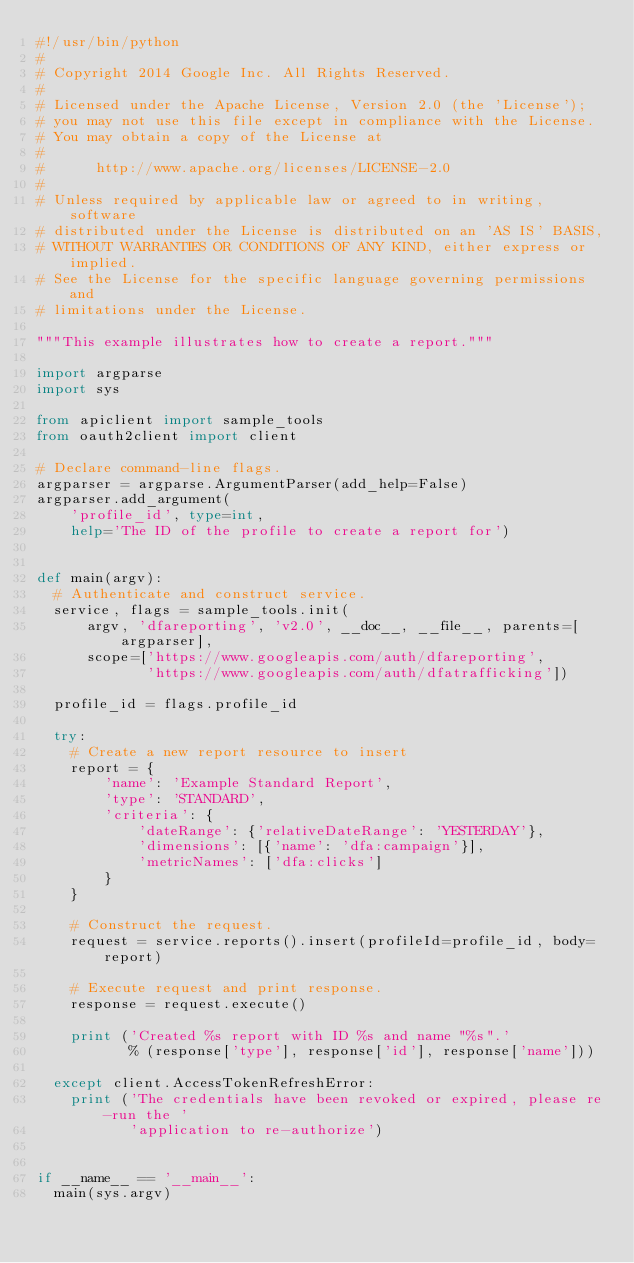Convert code to text. <code><loc_0><loc_0><loc_500><loc_500><_Python_>#!/usr/bin/python
#
# Copyright 2014 Google Inc. All Rights Reserved.
#
# Licensed under the Apache License, Version 2.0 (the 'License');
# you may not use this file except in compliance with the License.
# You may obtain a copy of the License at
#
#      http://www.apache.org/licenses/LICENSE-2.0
#
# Unless required by applicable law or agreed to in writing, software
# distributed under the License is distributed on an 'AS IS' BASIS,
# WITHOUT WARRANTIES OR CONDITIONS OF ANY KIND, either express or implied.
# See the License for the specific language governing permissions and
# limitations under the License.

"""This example illustrates how to create a report."""

import argparse
import sys

from apiclient import sample_tools
from oauth2client import client

# Declare command-line flags.
argparser = argparse.ArgumentParser(add_help=False)
argparser.add_argument(
    'profile_id', type=int,
    help='The ID of the profile to create a report for')


def main(argv):
  # Authenticate and construct service.
  service, flags = sample_tools.init(
      argv, 'dfareporting', 'v2.0', __doc__, __file__, parents=[argparser],
      scope=['https://www.googleapis.com/auth/dfareporting',
             'https://www.googleapis.com/auth/dfatrafficking'])

  profile_id = flags.profile_id

  try:
    # Create a new report resource to insert
    report = {
        'name': 'Example Standard Report',
        'type': 'STANDARD',
        'criteria': {
            'dateRange': {'relativeDateRange': 'YESTERDAY'},
            'dimensions': [{'name': 'dfa:campaign'}],
            'metricNames': ['dfa:clicks']
        }
    }

    # Construct the request.
    request = service.reports().insert(profileId=profile_id, body=report)

    # Execute request and print response.
    response = request.execute()

    print ('Created %s report with ID %s and name "%s".'
           % (response['type'], response['id'], response['name']))

  except client.AccessTokenRefreshError:
    print ('The credentials have been revoked or expired, please re-run the '
           'application to re-authorize')


if __name__ == '__main__':
  main(sys.argv)
</code> 